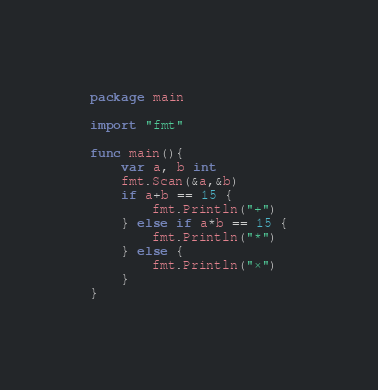<code> <loc_0><loc_0><loc_500><loc_500><_Go_>package main

import "fmt"

func main(){
	var a, b int
	fmt.Scan(&a,&b)
	if a+b == 15 {
		fmt.Println("+")
	} else if a*b == 15 {
		fmt.Println("*")
	} else {
		fmt.Println("×")
	}
}
</code> 